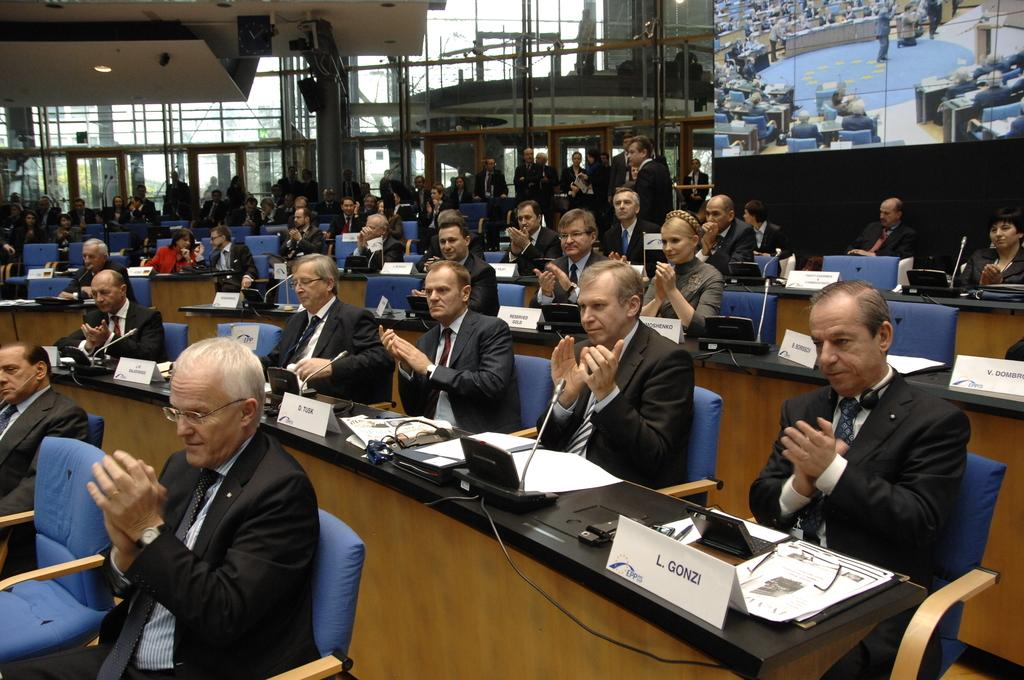What are the people in the image doing? The people in the image are sitting on chairs. Can you describe the setting in which the people are sitting? There is a building in the image, which suggests that the people are sitting indoors or in a structured outdoor area. How many pipes are visible in the image? There is no mention of pipes in the provided facts, so it cannot be determined how many pipes are visible in the image. 